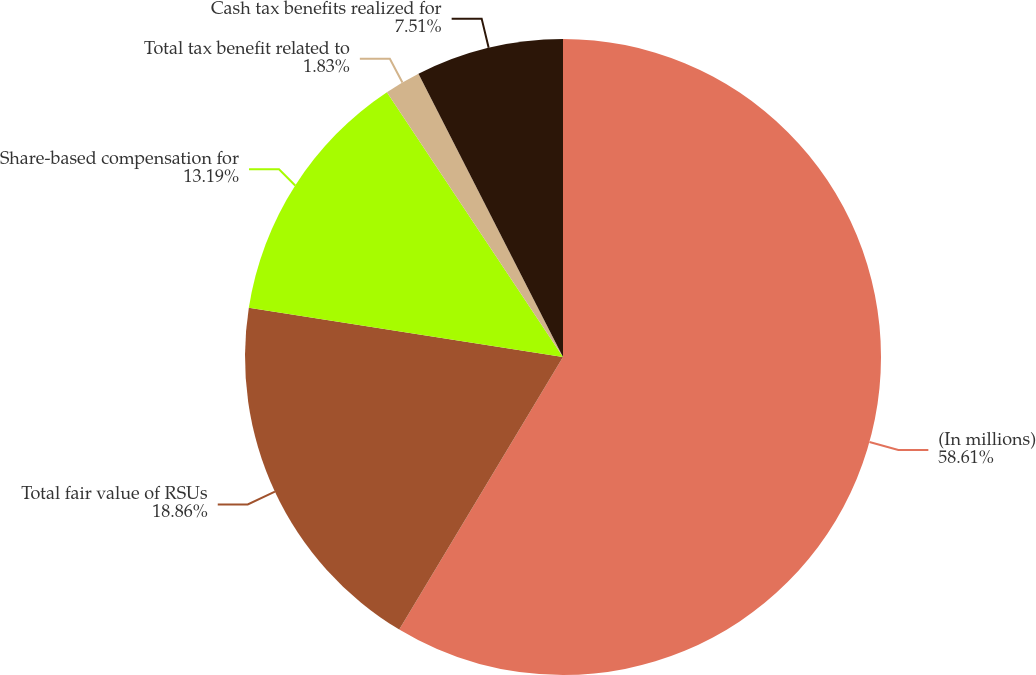Convert chart to OTSL. <chart><loc_0><loc_0><loc_500><loc_500><pie_chart><fcel>(In millions)<fcel>Total fair value of RSUs<fcel>Share-based compensation for<fcel>Total tax benefit related to<fcel>Cash tax benefits realized for<nl><fcel>58.61%<fcel>18.86%<fcel>13.19%<fcel>1.83%<fcel>7.51%<nl></chart> 